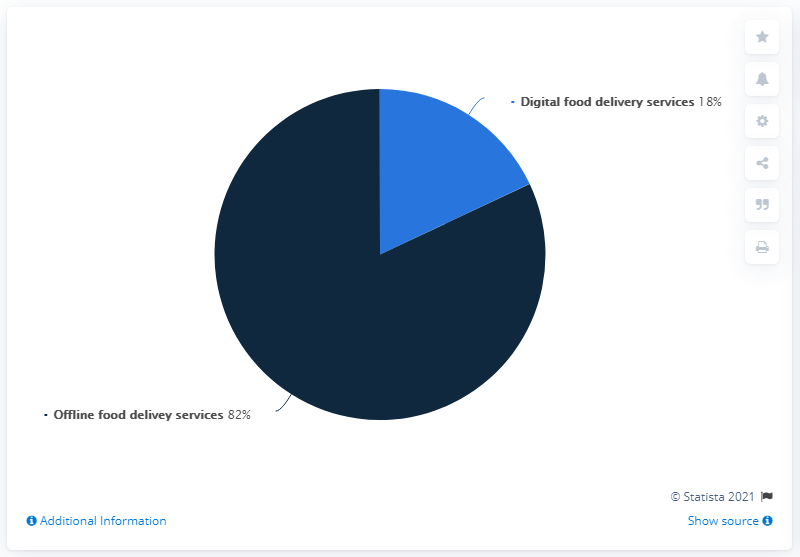Mention a couple of crucial points in this snapshot. A recent survey found that offline food delivery services make up 82% of the market. The cost of digital food delivery services is approximately 18 cents. 